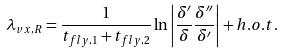<formula> <loc_0><loc_0><loc_500><loc_500>\lambda _ { v x , R } = \frac { 1 } { t _ { f l y , 1 } + t _ { f l y , 2 } } \ln \left | \frac { \delta ^ { \prime } } { \delta } \frac { \delta ^ { \prime \prime } } { \delta ^ { \prime } } \right | + h . o . t .</formula> 